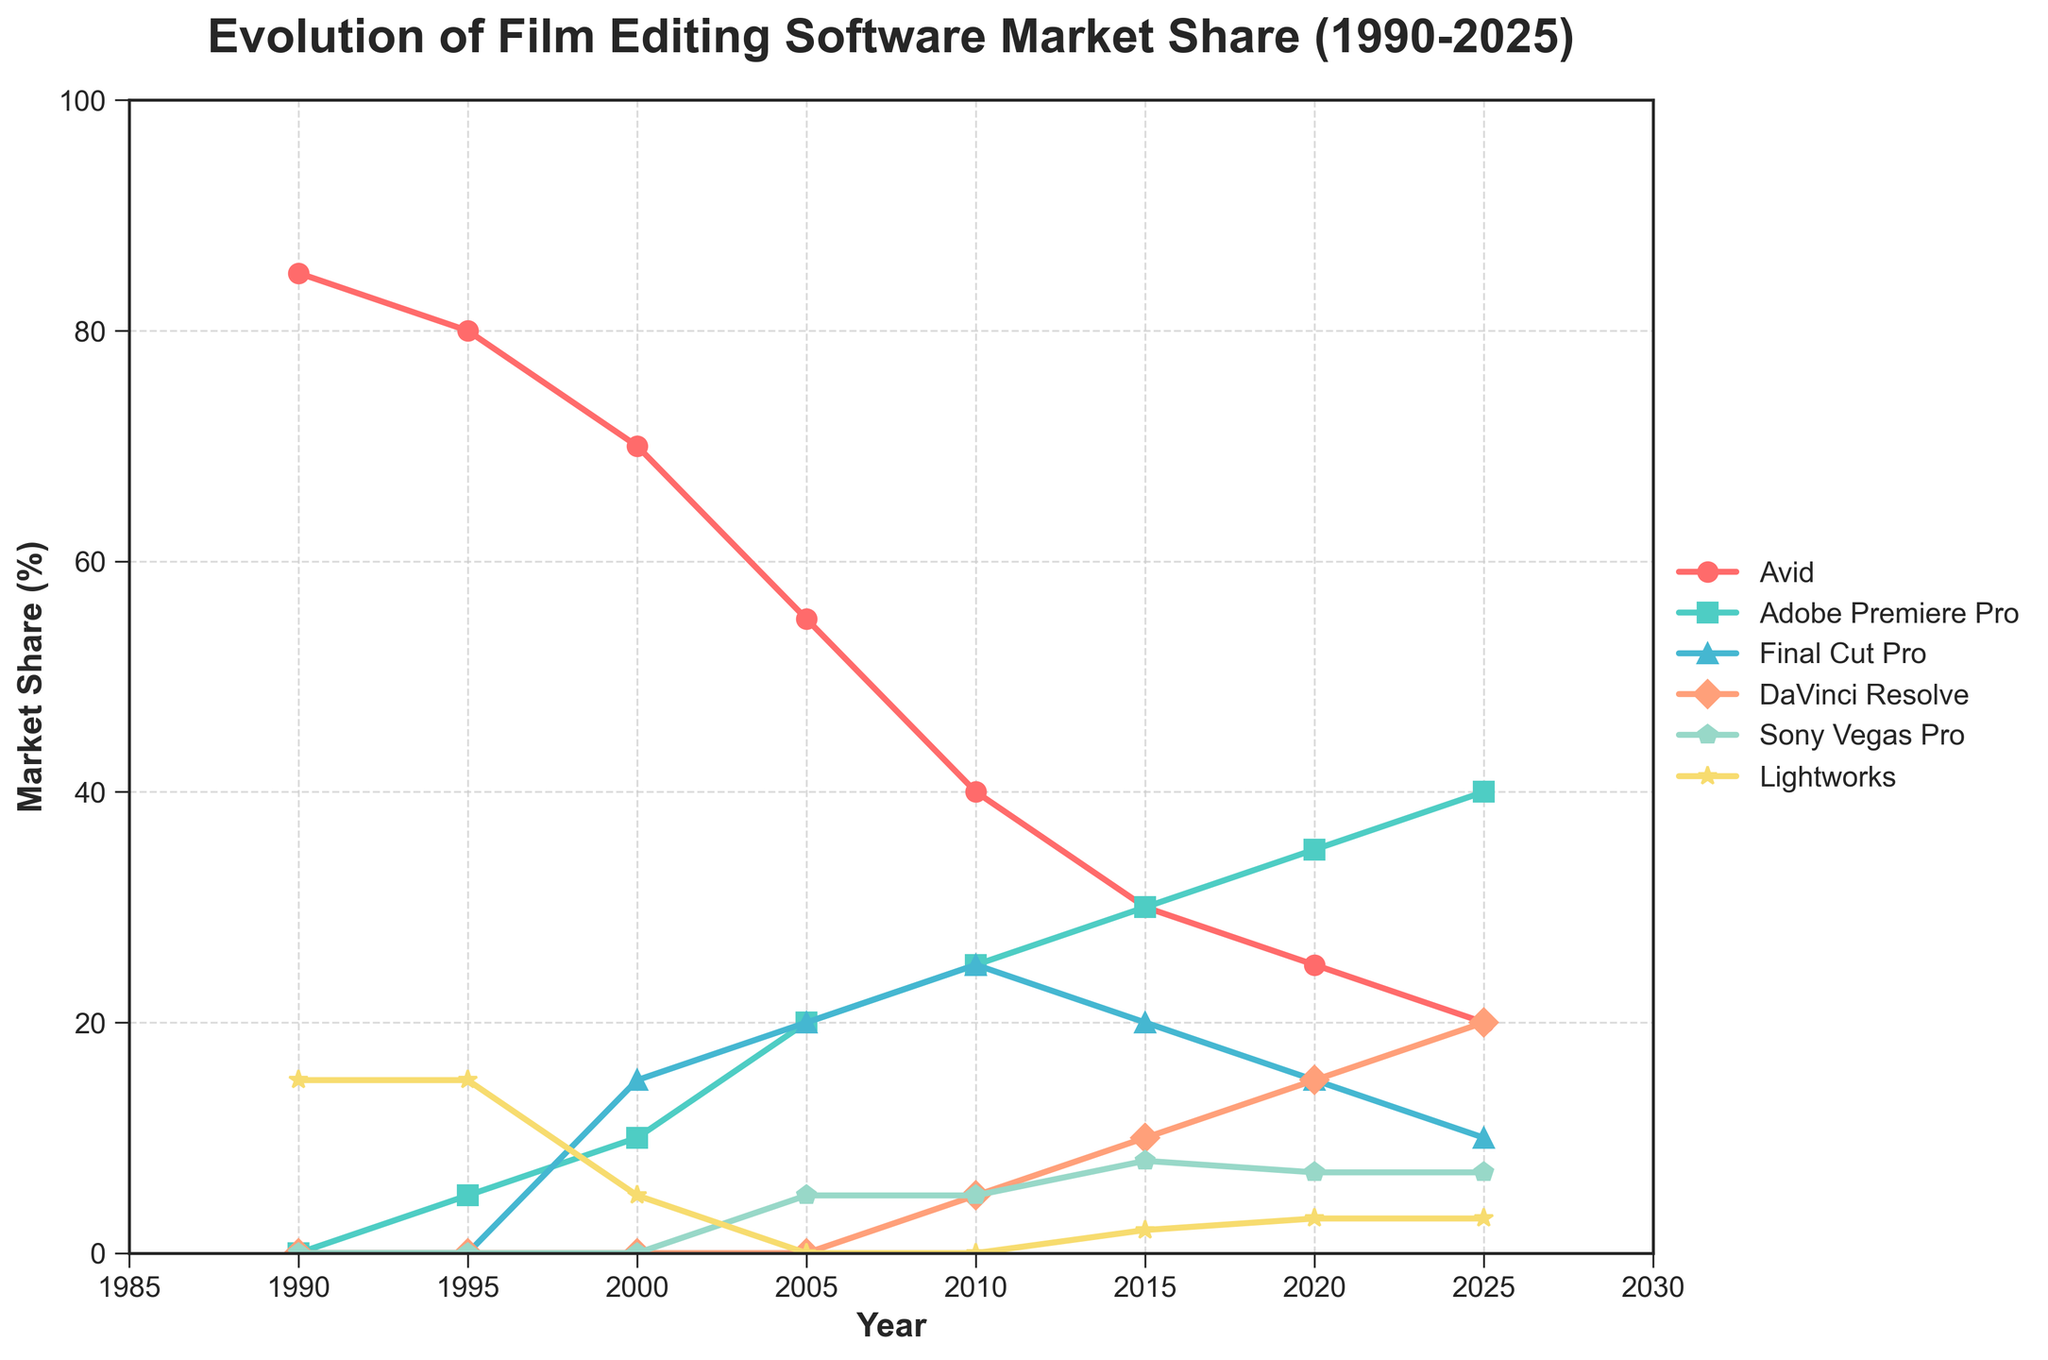What's the market share of Avid in 1990 compared to 2025? To find this answer, look at the market share of Avid in both 1990 and 2025. In 1990, Avid has a market share of 85%, and in 2025, it's down to 20%. So, there's a decrease of 65 percentage points over the period.
Answer: Avid's market share decreased by 65 percentage points Which software had the highest market share in 2010? In 2010, the software with the highest market share is Final Cut Pro and Avid, both at 25%.
Answer: Final Cut Pro and Avid Between 1995 and 2005, which software saw the biggest increase in market share? From 1995 to 2005, Adobe Premiere Pro's market share increased from 5% to 20%, an increase of 15 percentage points.
Answer: Adobe Premiere Pro By how much did DaVinci Resolve's market share change from 2010 to 2015? DaVinci Resolve's market share in 2010 is 5%, and it increased to 10% in 2015, so the change is 5 percentage points.
Answer: 5 percentage points Comparing Adobe Premiere Pro and Final Cut Pro in 2020, which one had a higher market share and by how much? In 2020, Adobe Premiere Pro has a market share of 35% while Final Cut Pro has 15%. The difference is 20 percentage points.
Answer: Adobe Premiere Pro by 20 percentage points What is the combined market share of Sony Vegas Pro and Lightworks in 2005? In 2005, Sony Vegas Pro has a market share of 5% and Lightworks has 0%. The combined market share is 5% + 0% = 5%.
Answer: 5% Which software experienced the most significant decline in market share from 1990 to 2025? Avid had the highest market share in 1990 at 85% and it declined to 20% in 2025, which is a decrease of 65 percentage points, the most significant decline among all software.
Answer: Avid How does the market share of Lightworks in 1990 compare to its market share in 2025? In 1990, Lightworks had a market share of 15%, and in 2025, it is 3%. This is a decrease of 12 percentage points.
Answer: Decreased by 12 percentage points What is the market share difference between the leading software in 2025 and the leading software in 1990? In 2025, Adobe Premiere Pro is leading with 40%, while in 1990, Avid was leading with 85%. The difference is 45 percentage points.
Answer: 45 percentage points Which software had a market share of 35% at some point, and in which year? Adobe Premiere Pro had a market share of 35% in the year 2020.
Answer: Adobe Premiere Pro, 2020 